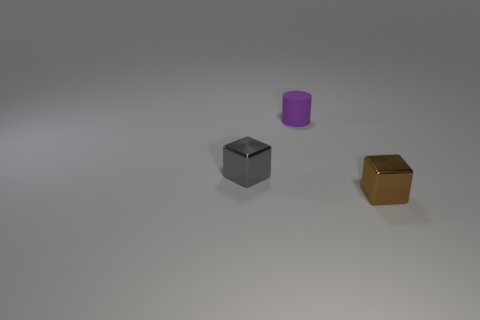Add 2 tiny spheres. How many objects exist? 5 Subtract all blocks. How many objects are left? 1 Subtract 0 green blocks. How many objects are left? 3 Subtract all rubber things. Subtract all small yellow rubber cubes. How many objects are left? 2 Add 1 purple cylinders. How many purple cylinders are left? 2 Add 1 cylinders. How many cylinders exist? 2 